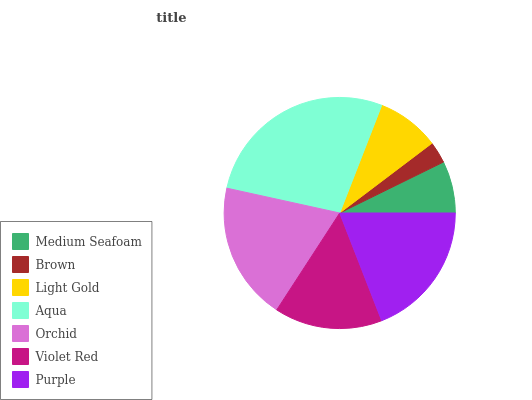Is Brown the minimum?
Answer yes or no. Yes. Is Aqua the maximum?
Answer yes or no. Yes. Is Light Gold the minimum?
Answer yes or no. No. Is Light Gold the maximum?
Answer yes or no. No. Is Light Gold greater than Brown?
Answer yes or no. Yes. Is Brown less than Light Gold?
Answer yes or no. Yes. Is Brown greater than Light Gold?
Answer yes or no. No. Is Light Gold less than Brown?
Answer yes or no. No. Is Violet Red the high median?
Answer yes or no. Yes. Is Violet Red the low median?
Answer yes or no. Yes. Is Brown the high median?
Answer yes or no. No. Is Aqua the low median?
Answer yes or no. No. 